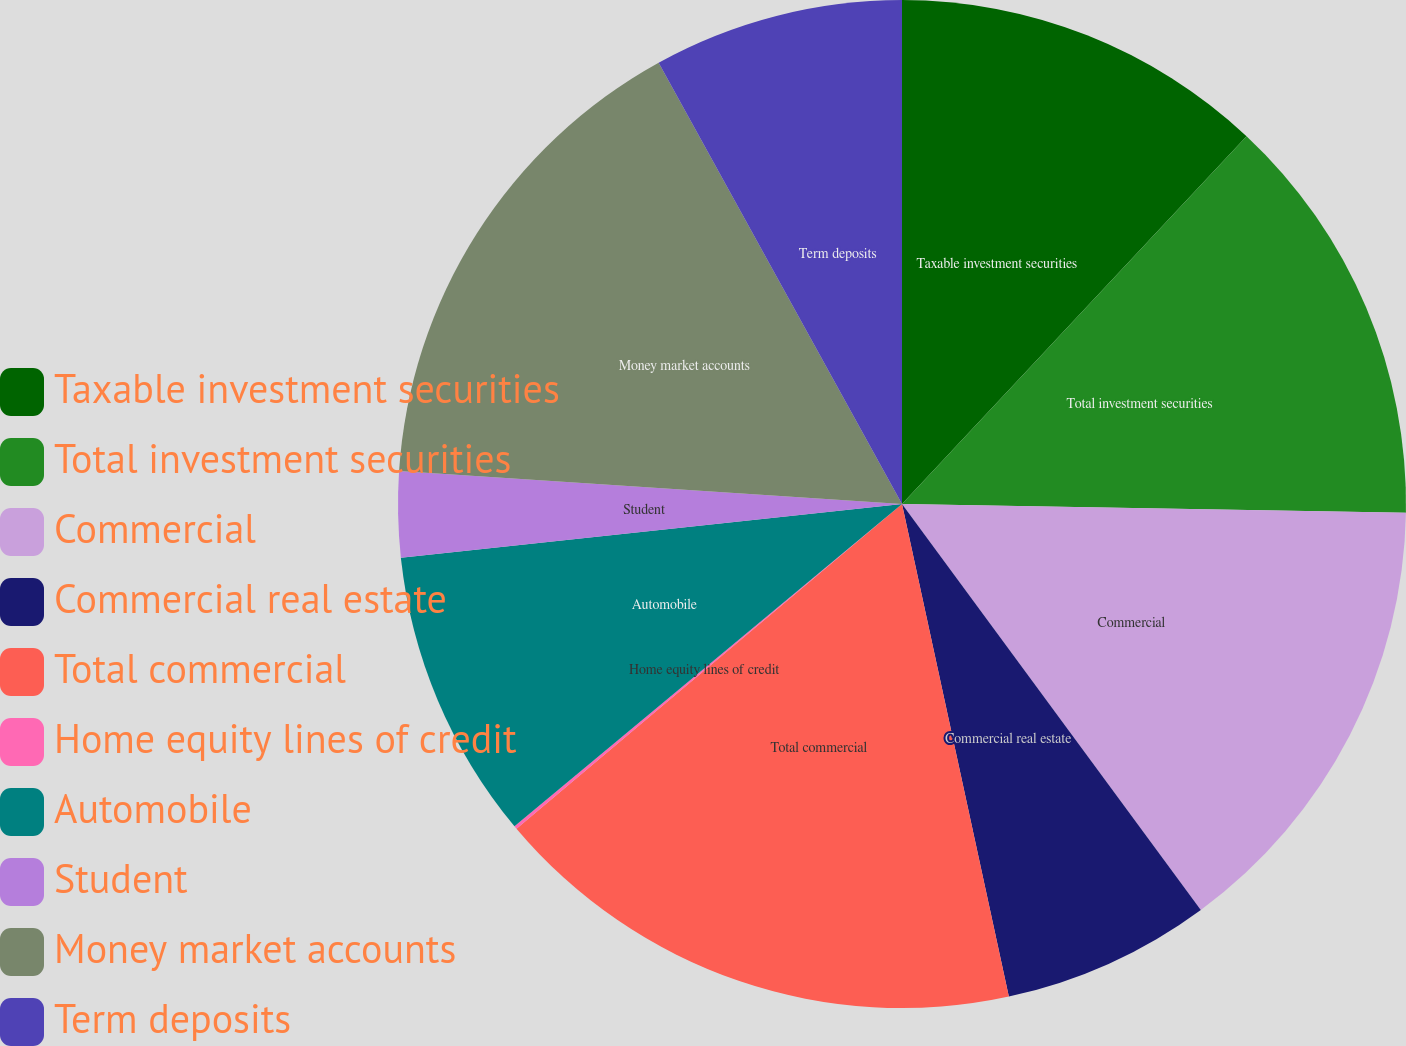Convert chart. <chart><loc_0><loc_0><loc_500><loc_500><pie_chart><fcel>Taxable investment securities<fcel>Total investment securities<fcel>Commercial<fcel>Commercial real estate<fcel>Total commercial<fcel>Home equity lines of credit<fcel>Automobile<fcel>Student<fcel>Money market accounts<fcel>Term deposits<nl><fcel>11.98%<fcel>13.3%<fcel>14.62%<fcel>6.7%<fcel>17.26%<fcel>0.1%<fcel>9.34%<fcel>2.74%<fcel>15.94%<fcel>8.02%<nl></chart> 